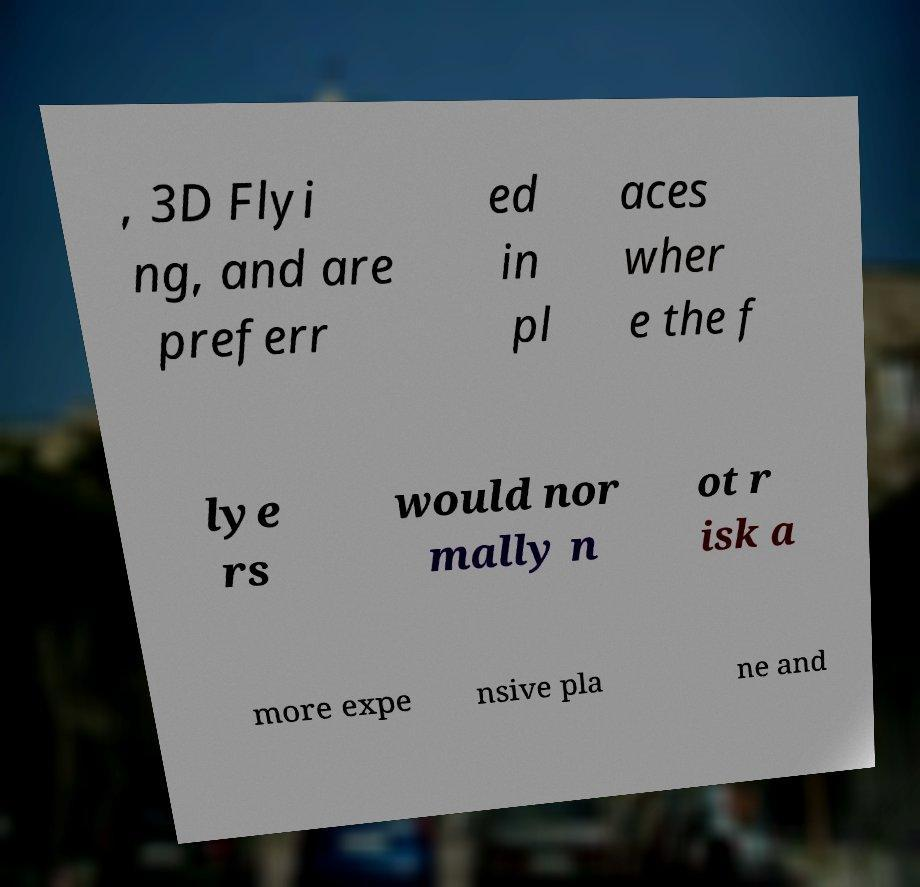For documentation purposes, I need the text within this image transcribed. Could you provide that? , 3D Flyi ng, and are preferr ed in pl aces wher e the f lye rs would nor mally n ot r isk a more expe nsive pla ne and 